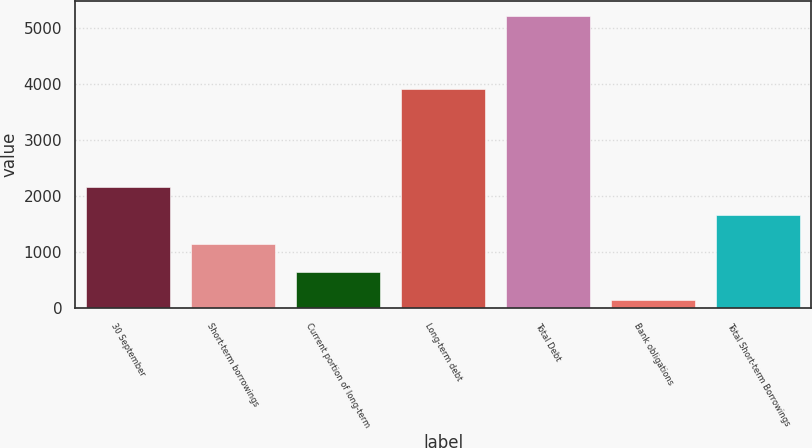<chart> <loc_0><loc_0><loc_500><loc_500><bar_chart><fcel>30 September<fcel>Short-term borrowings<fcel>Current portion of long-term<fcel>Long-term debt<fcel>Total Debt<fcel>Bank obligations<fcel>Total Short-term Borrowings<nl><fcel>2164.22<fcel>1148.66<fcel>640.88<fcel>3909.7<fcel>5210.9<fcel>133.1<fcel>1656.44<nl></chart> 